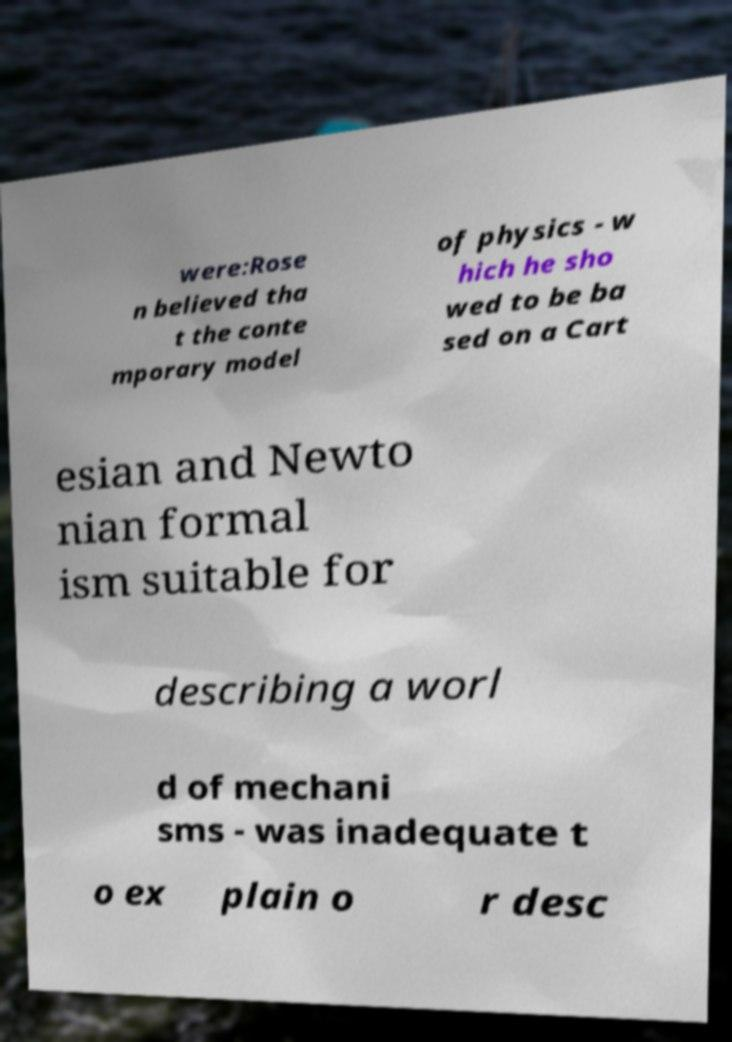Please read and relay the text visible in this image. What does it say? were:Rose n believed tha t the conte mporary model of physics - w hich he sho wed to be ba sed on a Cart esian and Newto nian formal ism suitable for describing a worl d of mechani sms - was inadequate t o ex plain o r desc 